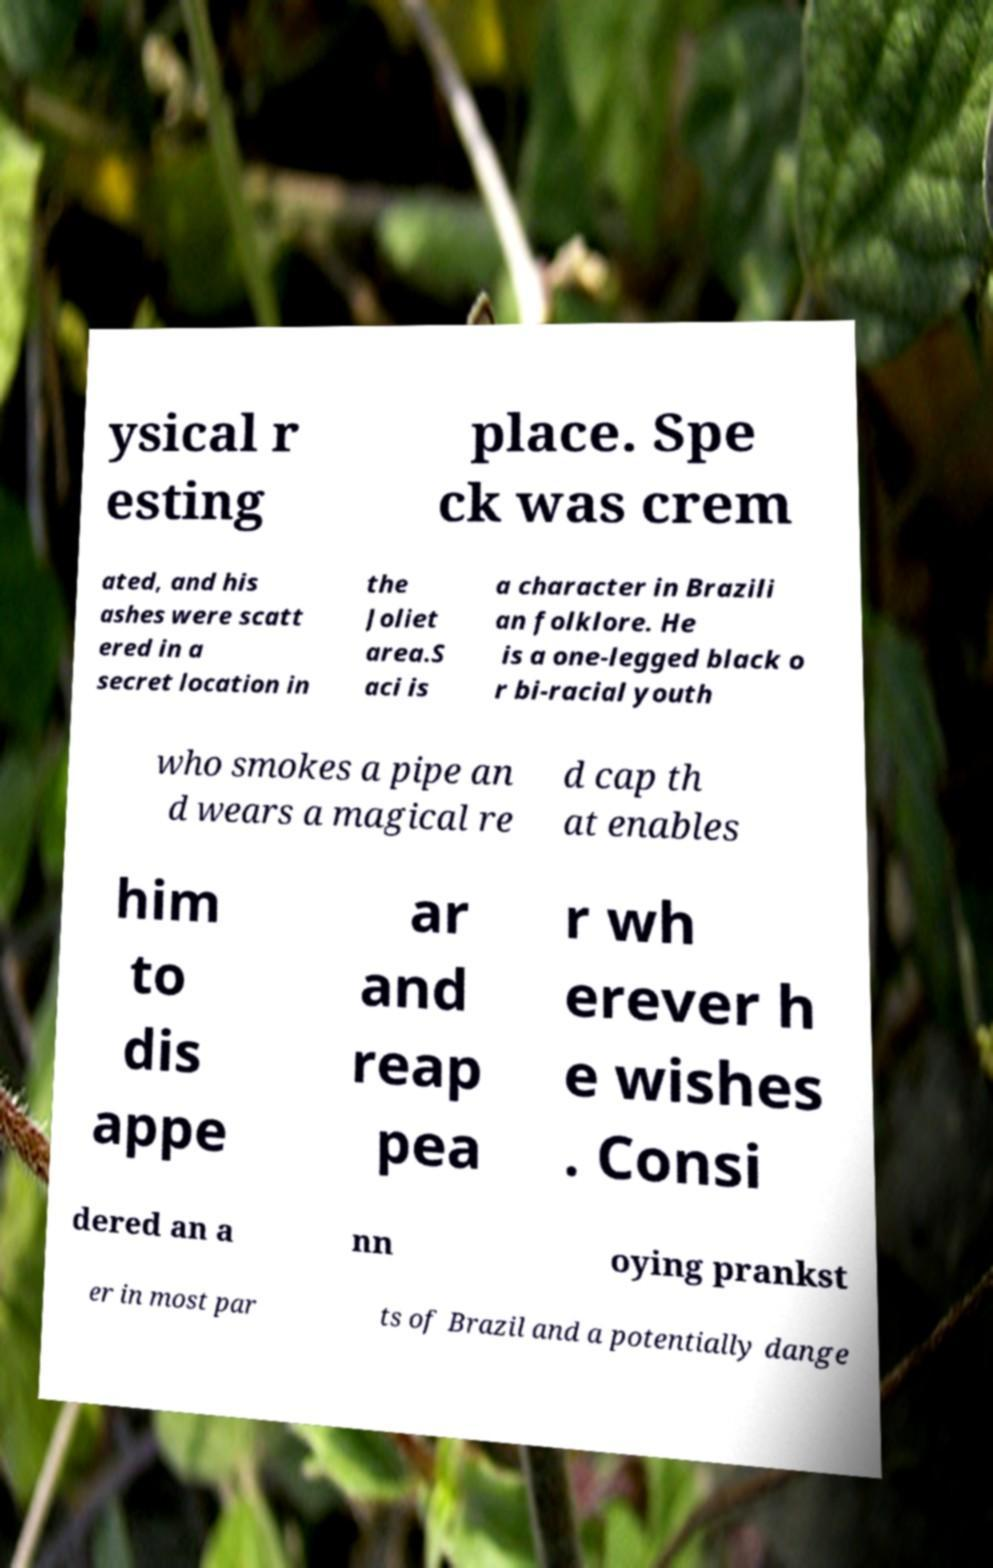Could you assist in decoding the text presented in this image and type it out clearly? ysical r esting place. Spe ck was crem ated, and his ashes were scatt ered in a secret location in the Joliet area.S aci is a character in Brazili an folklore. He is a one-legged black o r bi-racial youth who smokes a pipe an d wears a magical re d cap th at enables him to dis appe ar and reap pea r wh erever h e wishes . Consi dered an a nn oying prankst er in most par ts of Brazil and a potentially dange 